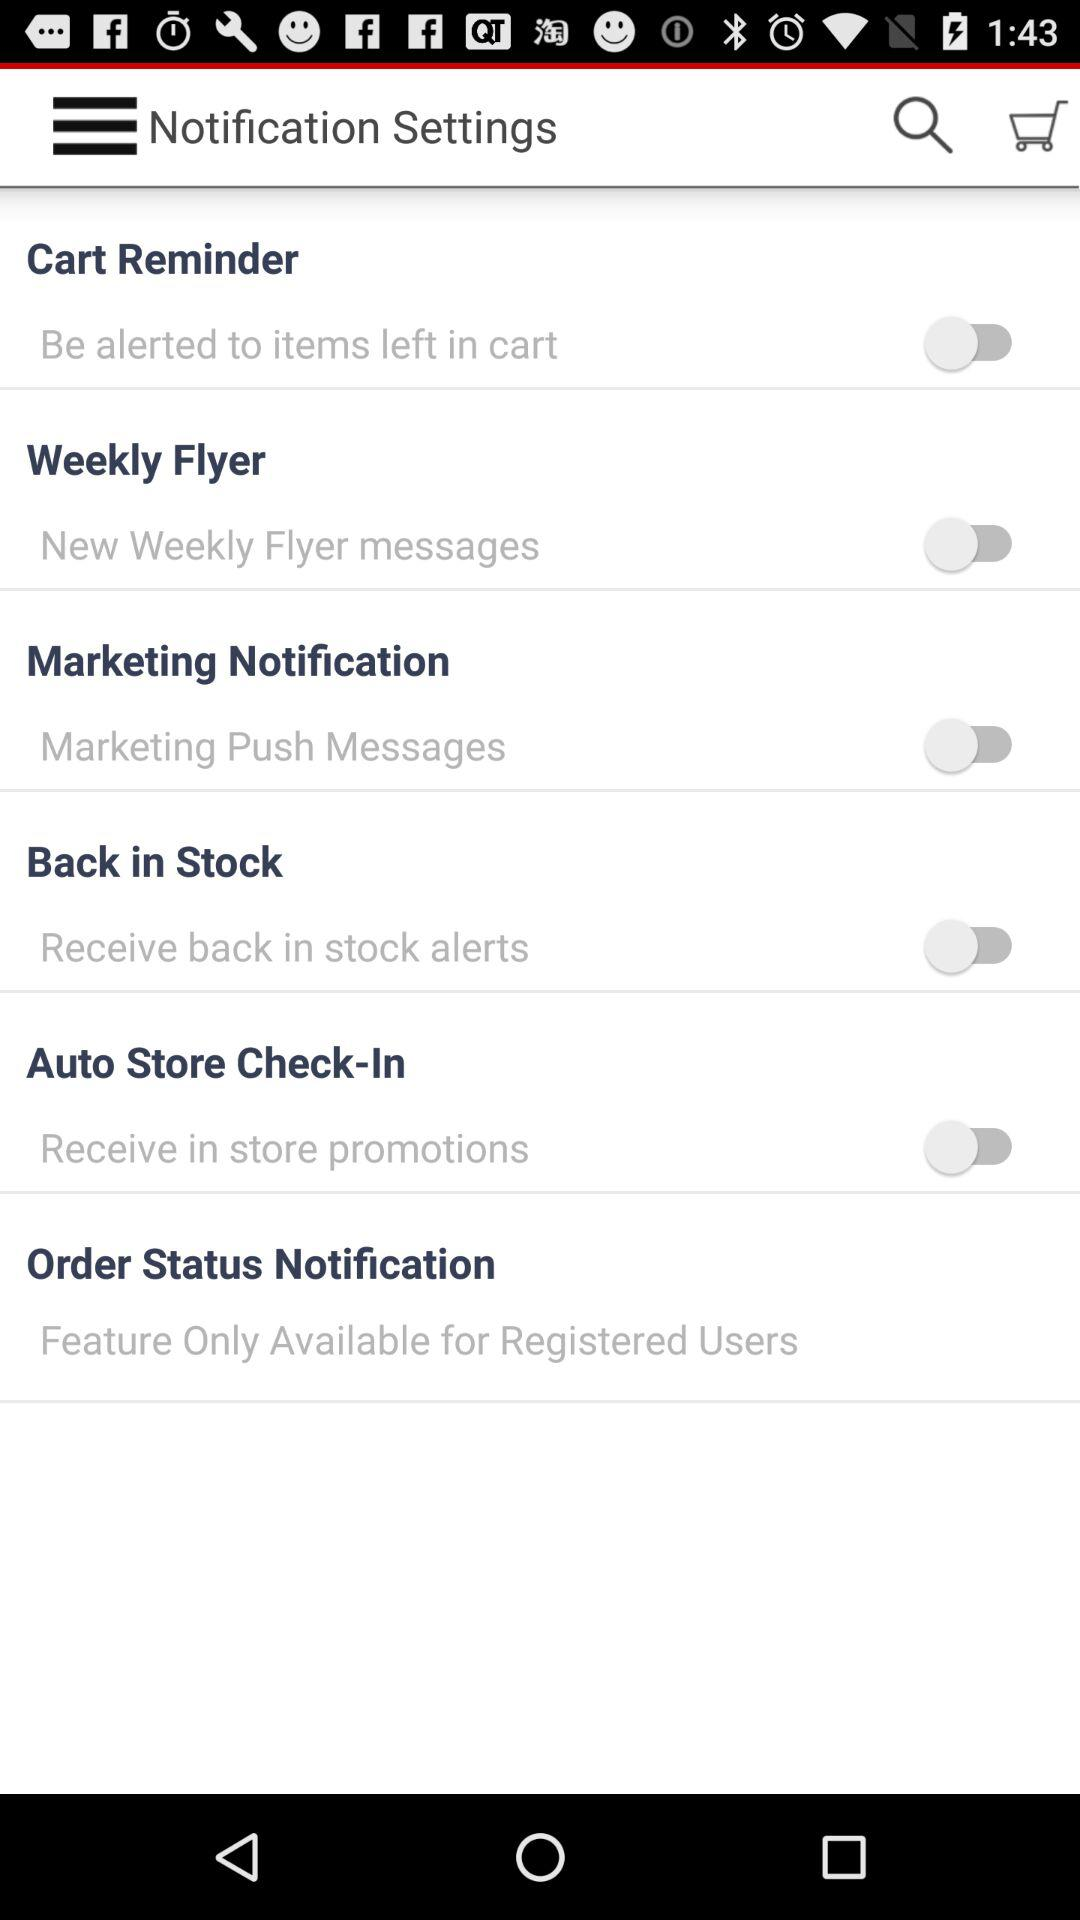What's the status of "Cart Reminder"? The status of "Cart Reminder" is "off". 